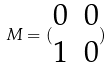<formula> <loc_0><loc_0><loc_500><loc_500>M = ( \begin{matrix} 0 & 0 \\ 1 & 0 \end{matrix} )</formula> 